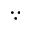<formula> <loc_0><loc_0><loc_500><loc_500>\because</formula> 